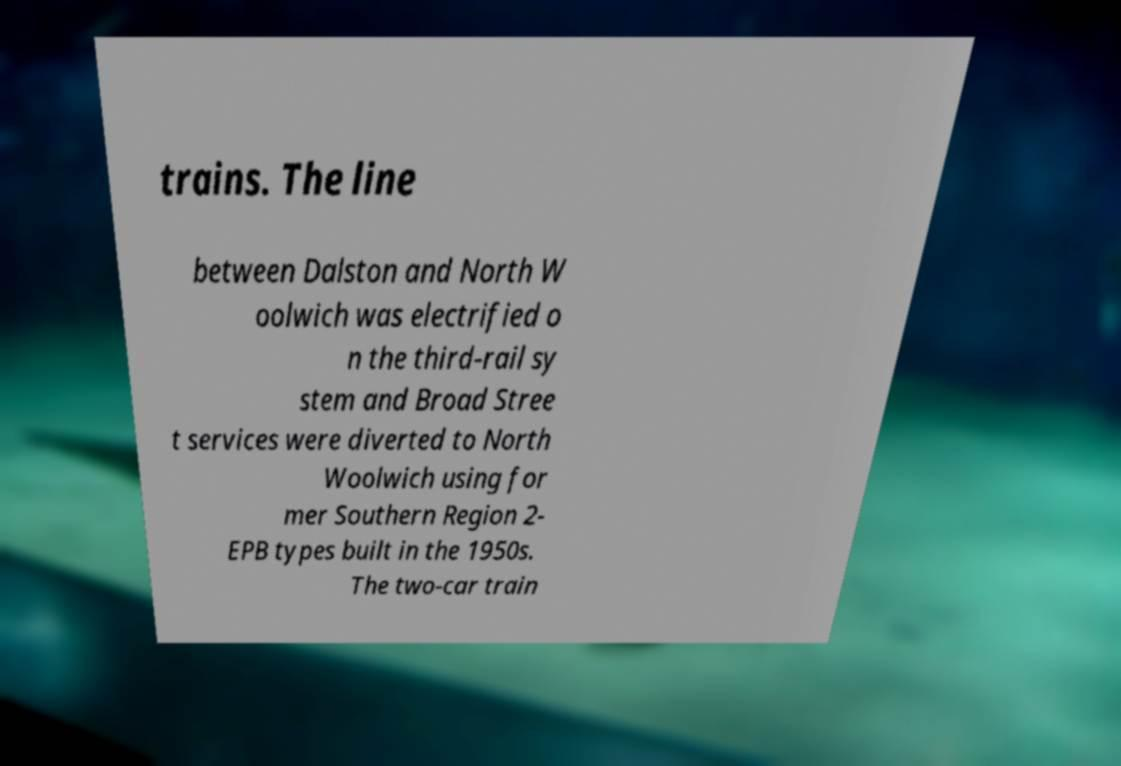Please read and relay the text visible in this image. What does it say? trains. The line between Dalston and North W oolwich was electrified o n the third-rail sy stem and Broad Stree t services were diverted to North Woolwich using for mer Southern Region 2- EPB types built in the 1950s. The two-car train 